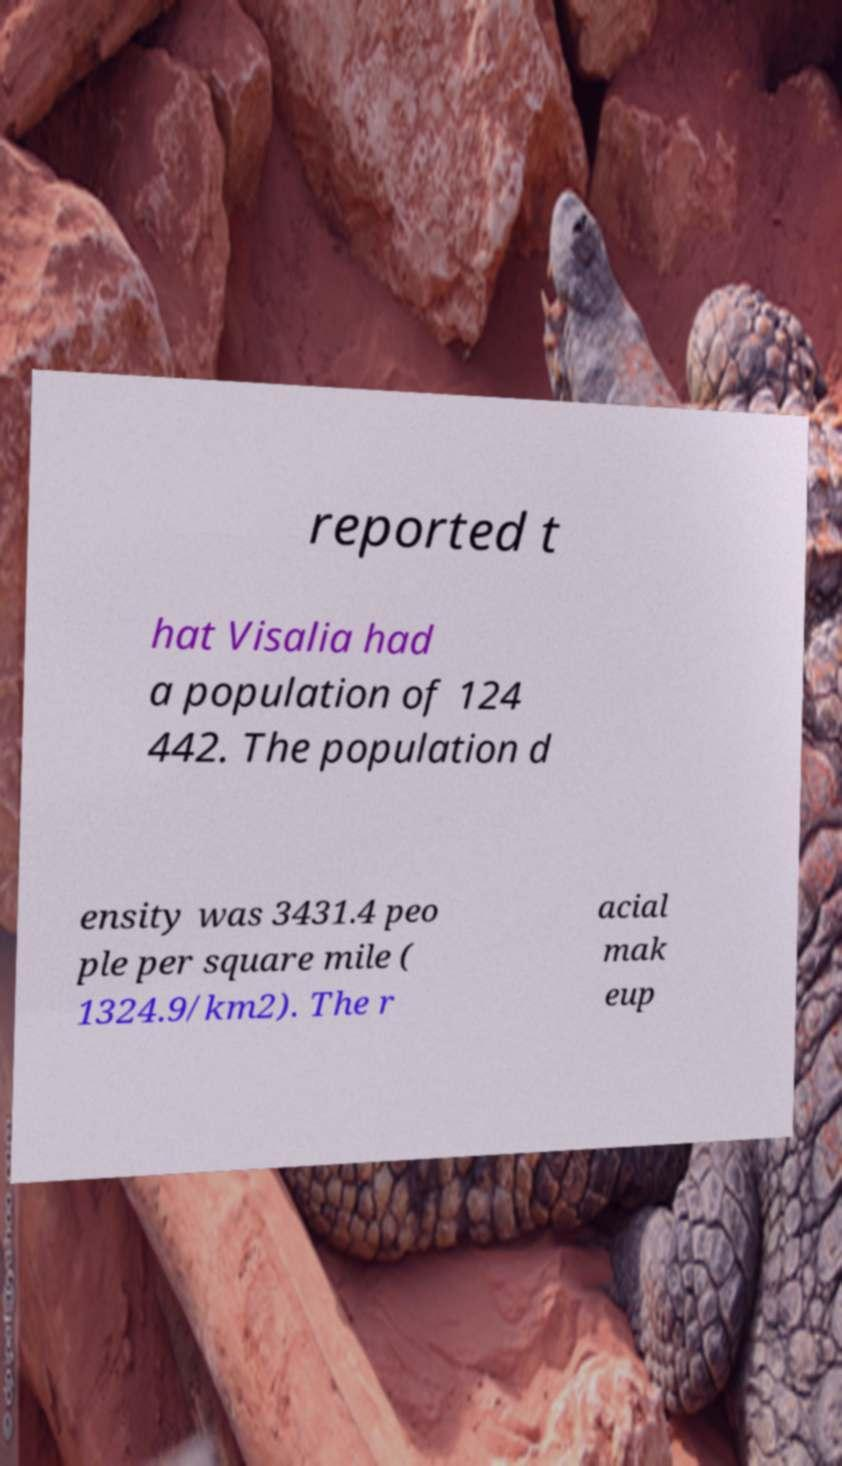Please identify and transcribe the text found in this image. reported t hat Visalia had a population of 124 442. The population d ensity was 3431.4 peo ple per square mile ( 1324.9/km2). The r acial mak eup 